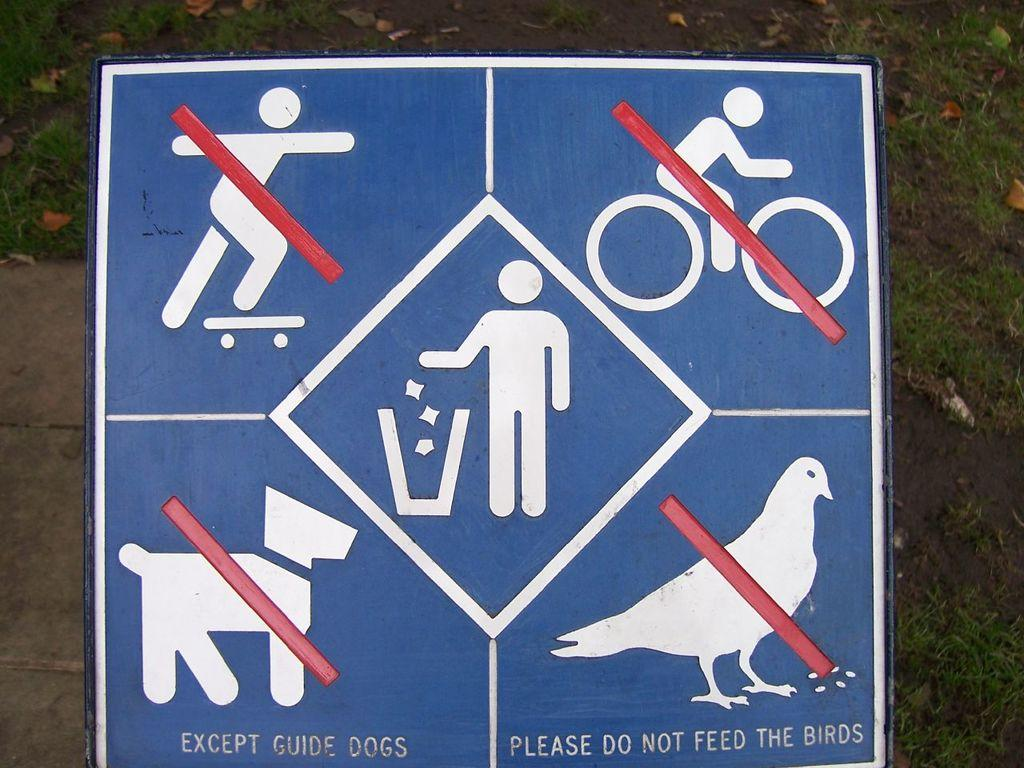What is the main object in the image? There is a board with text and signs in the image. Where is the board located in the image? The board is in the front of the image. What type of surface is visible on the ground in the image? There is grass on the ground in the image. What type of polish is being applied to the spade in the image? There is no spade or polish present in the image; it only features a board with text and signs, and grass on the ground. 